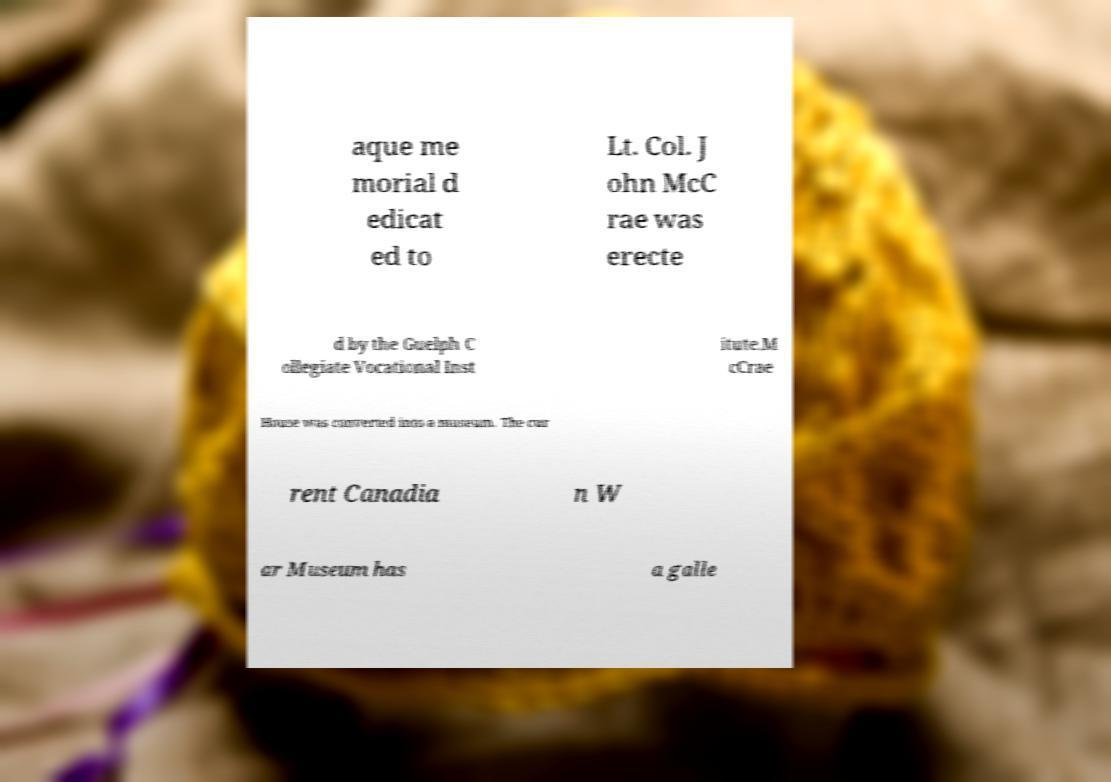Please read and relay the text visible in this image. What does it say? aque me morial d edicat ed to Lt. Col. J ohn McC rae was erecte d by the Guelph C ollegiate Vocational Inst itute.M cCrae House was converted into a museum. The cur rent Canadia n W ar Museum has a galle 